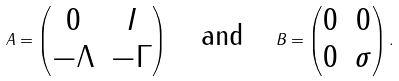<formula> <loc_0><loc_0><loc_500><loc_500>A = \begin{pmatrix} 0 & I \\ - \Lambda & - \Gamma \\ \end{pmatrix} \quad \text {and} \quad B = \begin{pmatrix} 0 & 0 \\ 0 & \sigma \\ \end{pmatrix} .</formula> 